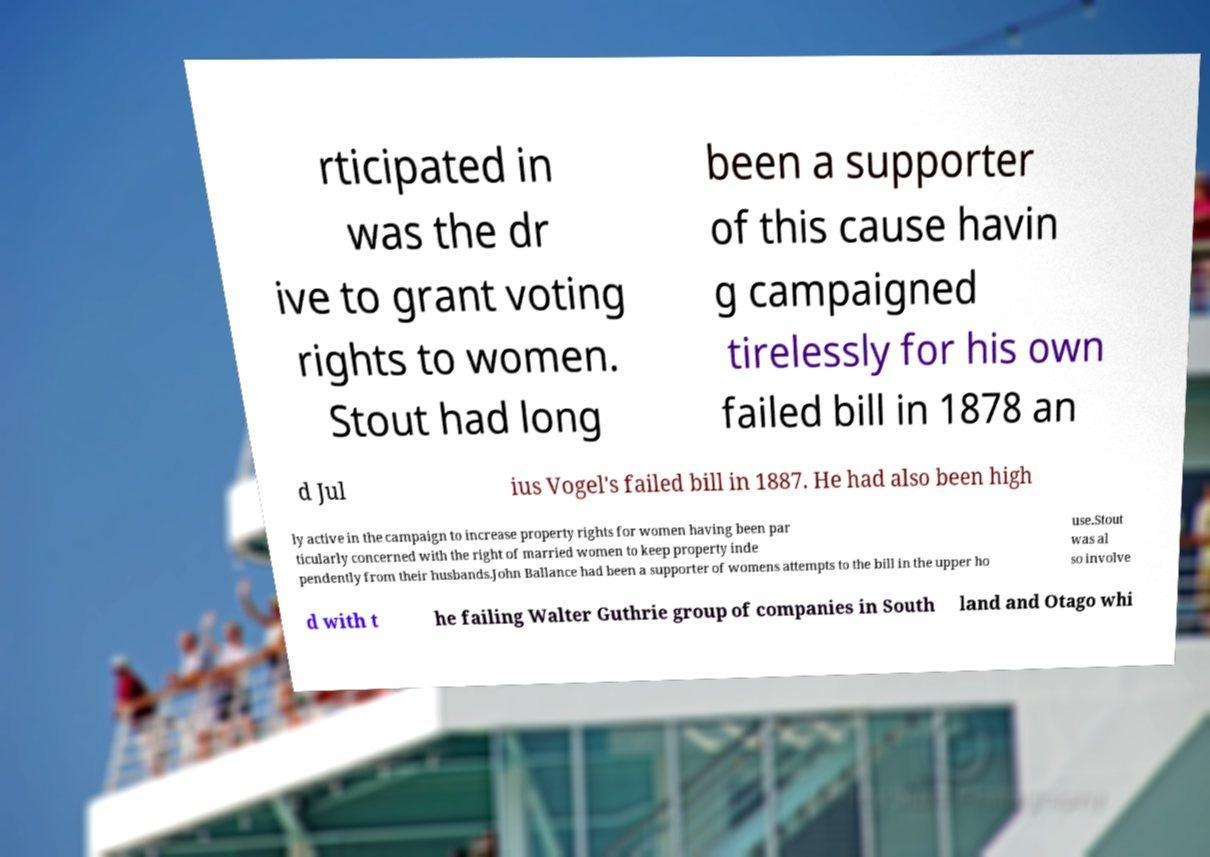For documentation purposes, I need the text within this image transcribed. Could you provide that? rticipated in was the dr ive to grant voting rights to women. Stout had long been a supporter of this cause havin g campaigned tirelessly for his own failed bill in 1878 an d Jul ius Vogel's failed bill in 1887. He had also been high ly active in the campaign to increase property rights for women having been par ticularly concerned with the right of married women to keep property inde pendently from their husbands.John Ballance had been a supporter of womens attempts to the bill in the upper ho use.Stout was al so involve d with t he failing Walter Guthrie group of companies in South land and Otago whi 